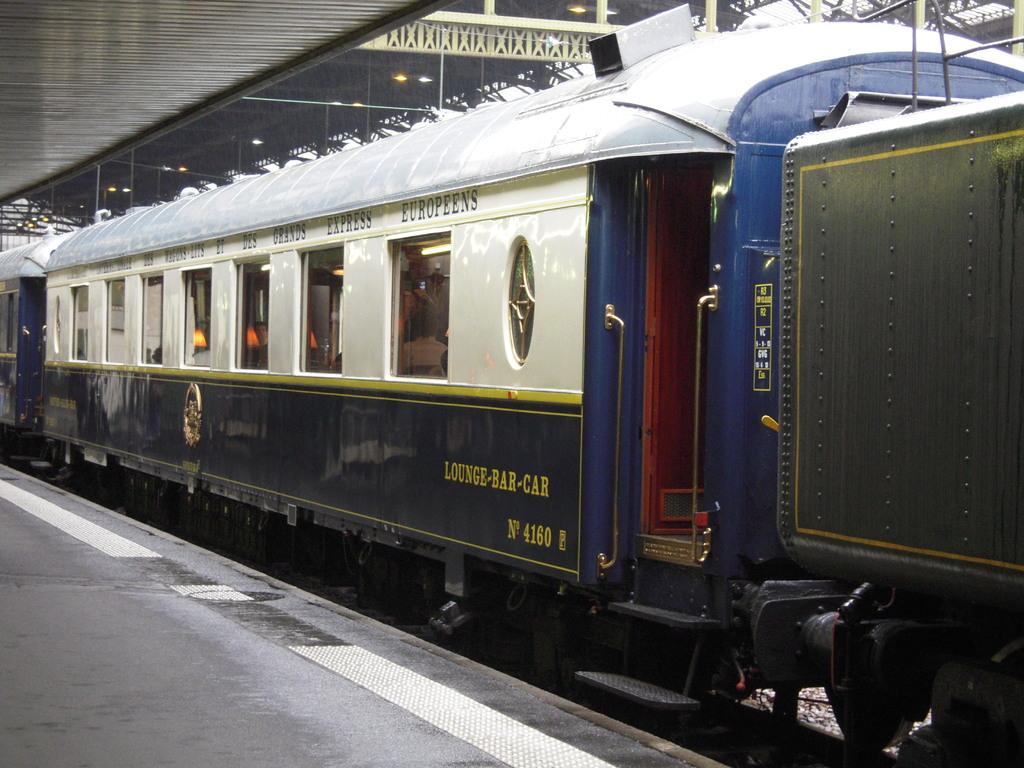What kind of car is this?
Provide a succinct answer. Lounge-bar. What is the number on this bar car?
Your answer should be compact. 4160. 